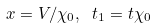<formula> <loc_0><loc_0><loc_500><loc_500>x = V / \chi _ { 0 } , \text { } t _ { 1 } = t \chi _ { 0 }</formula> 